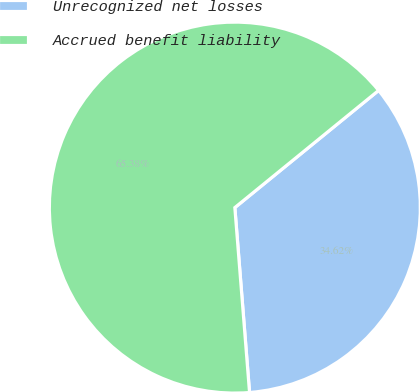Convert chart. <chart><loc_0><loc_0><loc_500><loc_500><pie_chart><fcel>Unrecognized net losses<fcel>Accrued benefit liability<nl><fcel>34.62%<fcel>65.38%<nl></chart> 